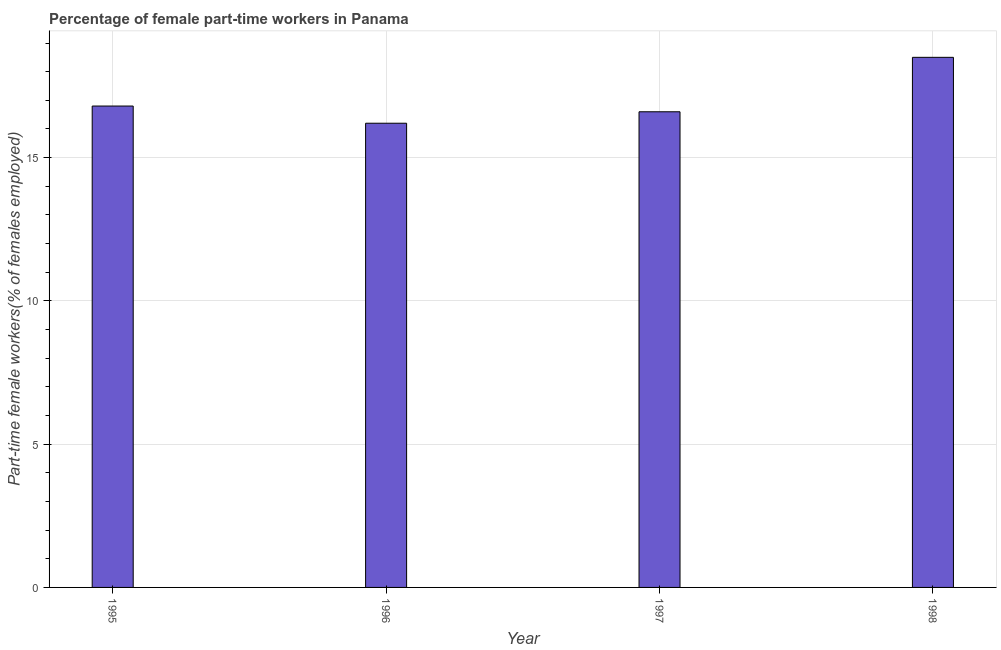Does the graph contain any zero values?
Offer a very short reply. No. Does the graph contain grids?
Provide a succinct answer. Yes. What is the title of the graph?
Make the answer very short. Percentage of female part-time workers in Panama. What is the label or title of the X-axis?
Give a very brief answer. Year. What is the label or title of the Y-axis?
Your response must be concise. Part-time female workers(% of females employed). What is the percentage of part-time female workers in 1998?
Give a very brief answer. 18.5. Across all years, what is the maximum percentage of part-time female workers?
Provide a succinct answer. 18.5. Across all years, what is the minimum percentage of part-time female workers?
Make the answer very short. 16.2. What is the sum of the percentage of part-time female workers?
Offer a very short reply. 68.1. What is the average percentage of part-time female workers per year?
Provide a short and direct response. 17.02. What is the median percentage of part-time female workers?
Make the answer very short. 16.7. In how many years, is the percentage of part-time female workers greater than 1 %?
Your response must be concise. 4. Do a majority of the years between 1998 and 1995 (inclusive) have percentage of part-time female workers greater than 8 %?
Give a very brief answer. Yes. What is the ratio of the percentage of part-time female workers in 1995 to that in 1996?
Offer a terse response. 1.04. Is the percentage of part-time female workers in 1996 less than that in 1997?
Your response must be concise. Yes. Is the difference between the percentage of part-time female workers in 1995 and 1998 greater than the difference between any two years?
Make the answer very short. No. Is the sum of the percentage of part-time female workers in 1995 and 1996 greater than the maximum percentage of part-time female workers across all years?
Your answer should be very brief. Yes. What is the difference between the highest and the lowest percentage of part-time female workers?
Keep it short and to the point. 2.3. In how many years, is the percentage of part-time female workers greater than the average percentage of part-time female workers taken over all years?
Your answer should be compact. 1. How many bars are there?
Offer a very short reply. 4. What is the difference between two consecutive major ticks on the Y-axis?
Offer a very short reply. 5. Are the values on the major ticks of Y-axis written in scientific E-notation?
Ensure brevity in your answer.  No. What is the Part-time female workers(% of females employed) in 1995?
Your answer should be very brief. 16.8. What is the Part-time female workers(% of females employed) of 1996?
Give a very brief answer. 16.2. What is the Part-time female workers(% of females employed) of 1997?
Offer a terse response. 16.6. What is the Part-time female workers(% of females employed) in 1998?
Provide a short and direct response. 18.5. What is the difference between the Part-time female workers(% of females employed) in 1995 and 1996?
Provide a succinct answer. 0.6. What is the difference between the Part-time female workers(% of females employed) in 1995 and 1997?
Your response must be concise. 0.2. What is the difference between the Part-time female workers(% of females employed) in 1995 and 1998?
Ensure brevity in your answer.  -1.7. What is the difference between the Part-time female workers(% of females employed) in 1996 and 1997?
Give a very brief answer. -0.4. What is the difference between the Part-time female workers(% of females employed) in 1996 and 1998?
Offer a very short reply. -2.3. What is the ratio of the Part-time female workers(% of females employed) in 1995 to that in 1998?
Make the answer very short. 0.91. What is the ratio of the Part-time female workers(% of females employed) in 1996 to that in 1998?
Keep it short and to the point. 0.88. What is the ratio of the Part-time female workers(% of females employed) in 1997 to that in 1998?
Make the answer very short. 0.9. 